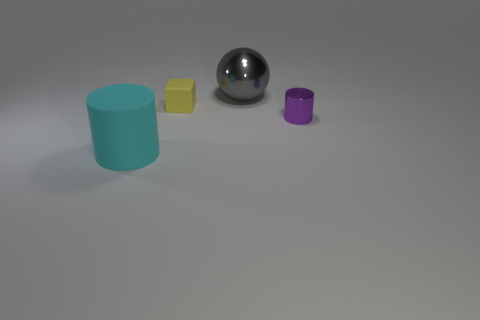Add 4 large cyan rubber cylinders. How many objects exist? 8 Subtract all purple cylinders. How many cylinders are left? 1 Subtract all spheres. How many objects are left? 3 Add 4 yellow rubber cubes. How many yellow rubber cubes exist? 5 Subtract 0 blue cubes. How many objects are left? 4 Subtract all blue cylinders. Subtract all purple cubes. How many cylinders are left? 2 Subtract all large cyan cubes. Subtract all small blocks. How many objects are left? 3 Add 1 tiny purple cylinders. How many tiny purple cylinders are left? 2 